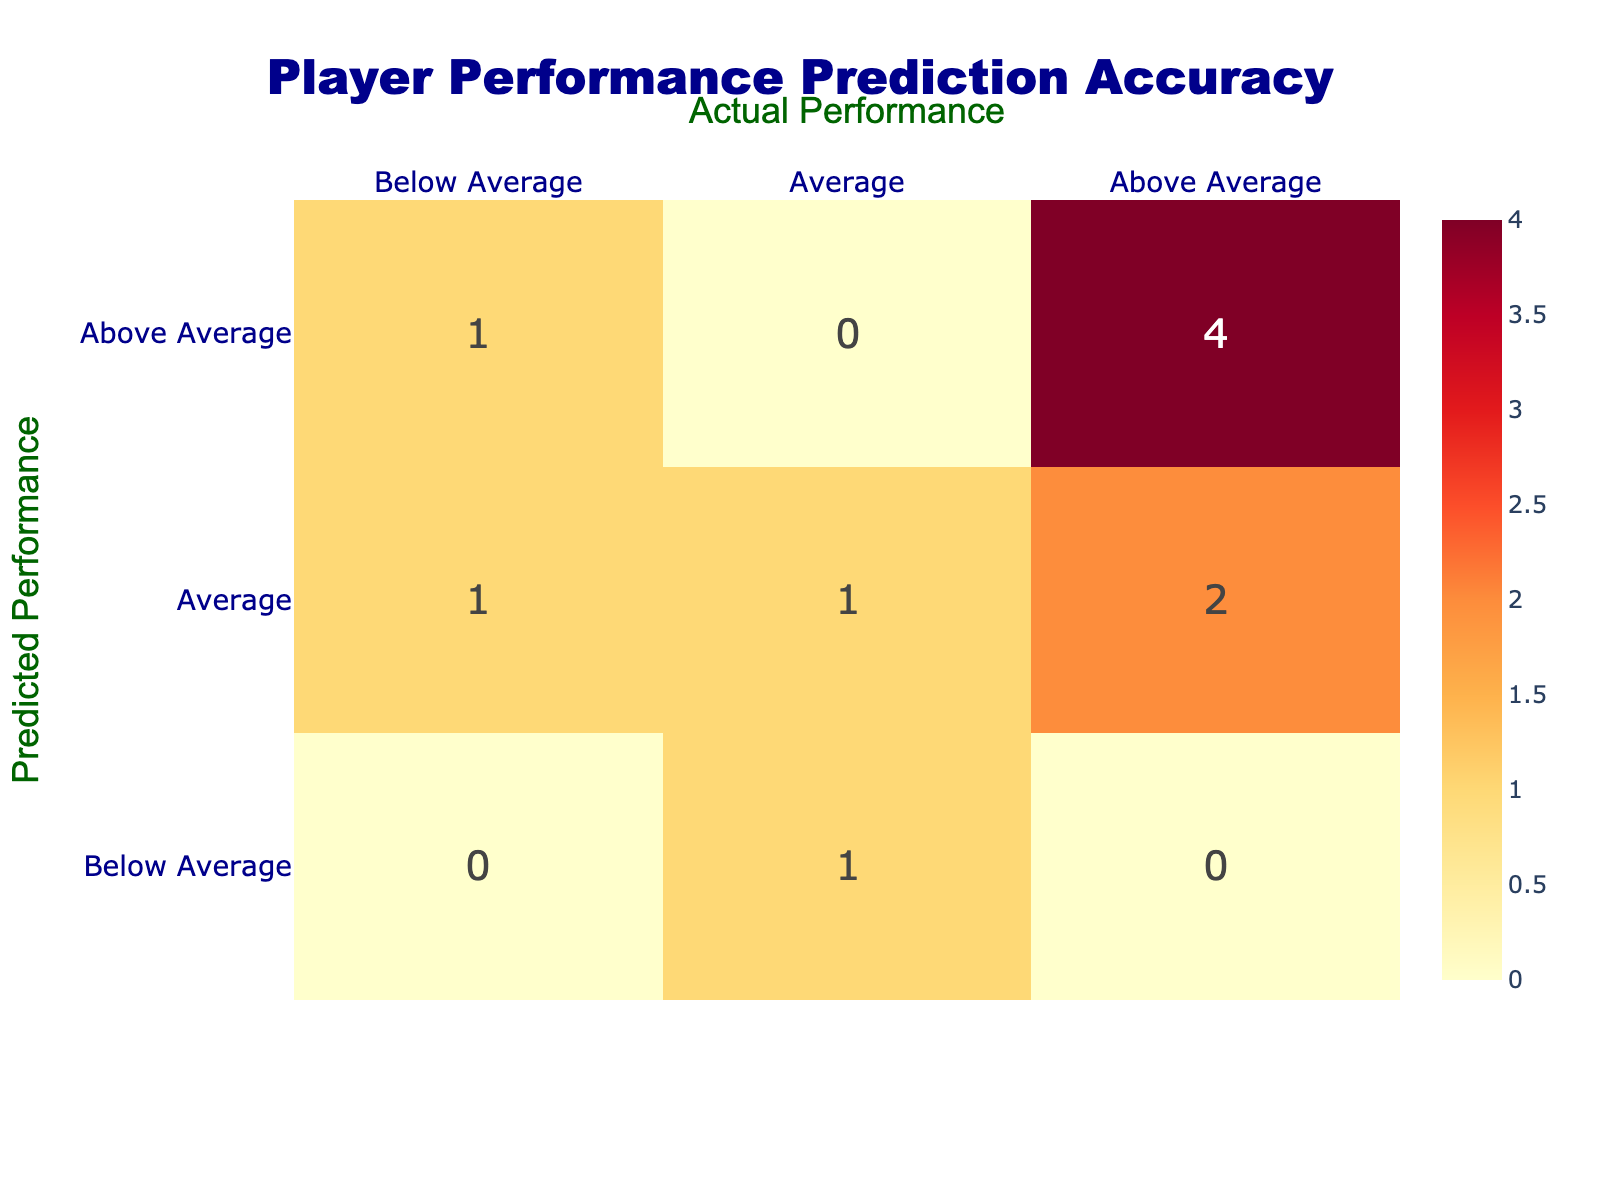What is the total number of players predicted to have "Above Average" performance? From the confusion matrix, we can count the number of players whose predicted performance is "Above Average." This includes LeBron James, Giannis Antetokounmpo, Luka Dončić, and Joel Embiid, which totals to 4 players.
Answer: 4 How many players' actual performance was "Below Average" according to the prediction? Looking at the table, the only players with an actual performance of "Below Average" are Stephen Curry and James Harden; thus, the total is 2 players.
Answer: 2 Is there any player whose predicted performance is "Below Average" and whose actual performance is also "Below Average"? The table shows Kawhi Leonard in the "Below Average" predicted category, but his actual performance is "Average." No players meet both criteria as all others either predicted Above Average or scored Average/Above Average.
Answer: No What is the percentage of players whose predicted performance matched their actual performance? There are 6 players whose predicted performance matches their actual performance (LeBron James, Giannis Antetokounmpo, Luka Dončić, Damian Lillard, Joel Embiid, and Kevin Durant with the only mismatch being Stephen Curry and James Harden). Thus, the percentage is (6/10)*100 = 60%.
Answer: 60 percent Which player had a predicted performance of "Average" but an actual performance of "Above Average"? Upon inspecting the table, Kevin Durant is the player who was predicted to have an "Average" performance but had an "Above Average" actual performance.
Answer: Kevin Durant How many players were predicted to be "Average"? Referring to the table, the players who were predicted to have an "Average" performance are Kevin Durant, James Harden, and Nikola Jokić. This totals to 3 players.
Answer: 3 What is the difference between the number of players predicted to perform "Above Average" and the number of those predicted "Below Average"? The counts of players are 4 predicted "Above Average" (LeBron James, Giannis Antetokounmpo, Luka Dončić, Joel Embiid) and 1 predicted "Below Average" (Kawhi Leonard). Therefore, the difference is 4 - 1 = 3.
Answer: 3 Did more players get predicted to have an "Average" or "Above Average" performance? The counts from the table show 4 players predicted as "Above Average" and 3 as "Average." Since 4 is greater than 3, more players were predicted to have "Above Average" performance.
Answer: Yes 